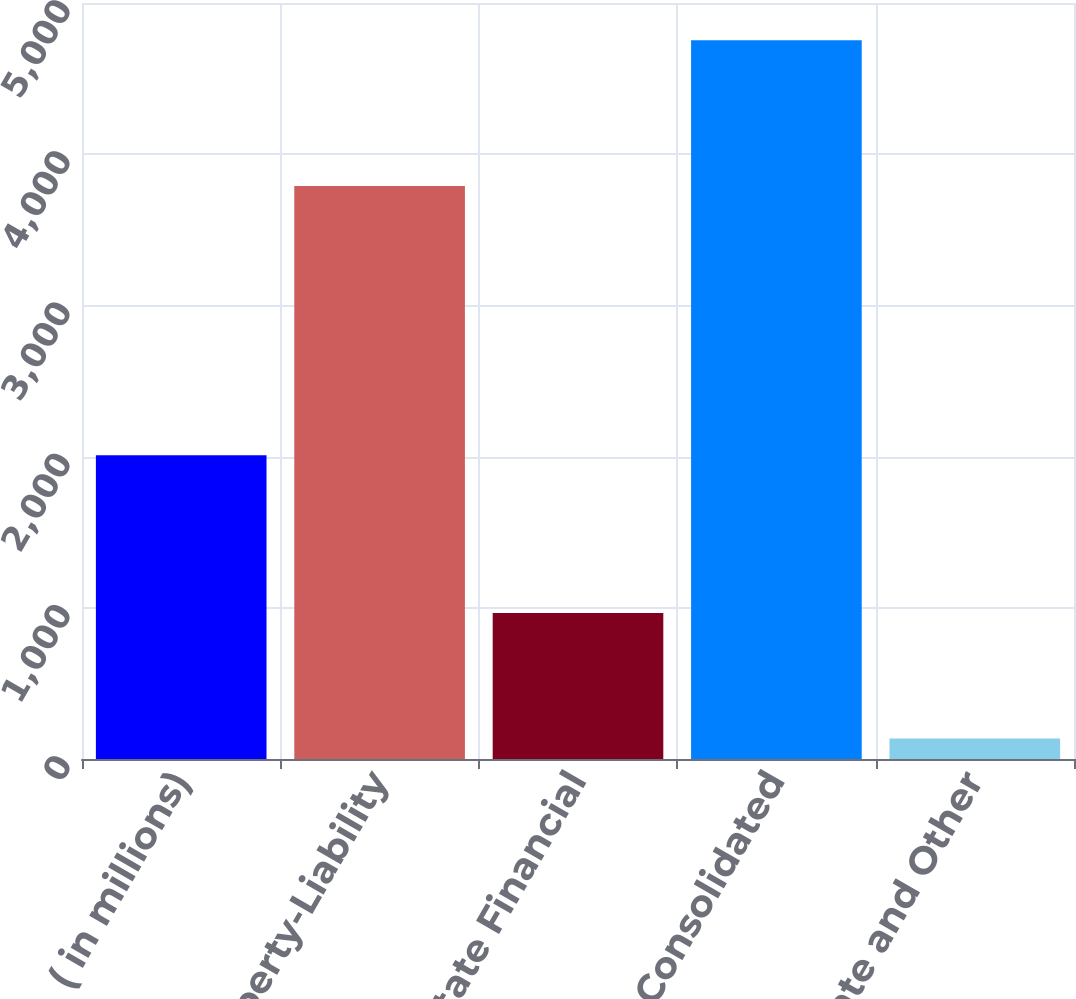Convert chart. <chart><loc_0><loc_0><loc_500><loc_500><bar_chart><fcel>( in millions)<fcel>Property-Liability<fcel>Allstate Financial<fcel>Consolidated<fcel>Corporate and Other<nl><fcel>2009<fcel>3789<fcel>965<fcel>4754<fcel>136<nl></chart> 